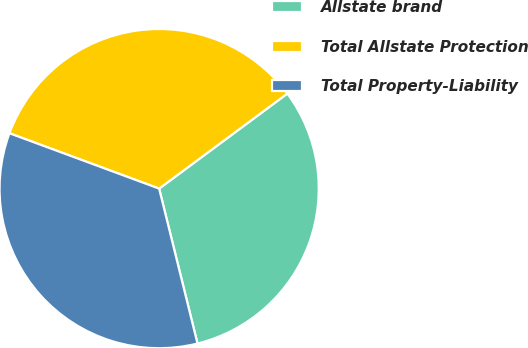<chart> <loc_0><loc_0><loc_500><loc_500><pie_chart><fcel>Allstate brand<fcel>Total Allstate Protection<fcel>Total Property-Liability<nl><fcel>31.29%<fcel>34.21%<fcel>34.5%<nl></chart> 